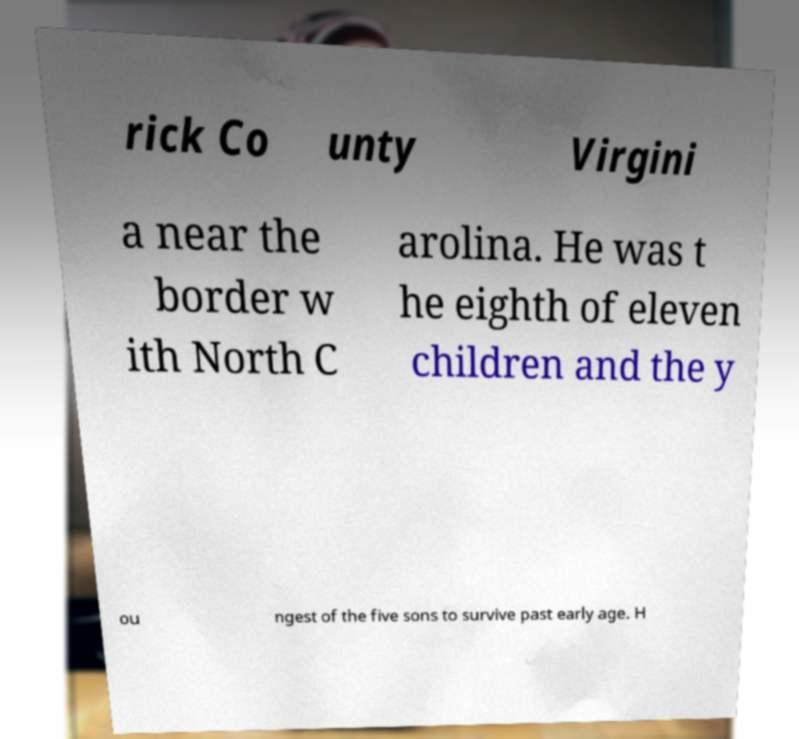I need the written content from this picture converted into text. Can you do that? rick Co unty Virgini a near the border w ith North C arolina. He was t he eighth of eleven children and the y ou ngest of the five sons to survive past early age. H 